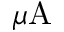Convert formula to latex. <formula><loc_0><loc_0><loc_500><loc_500>\mu A</formula> 